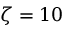<formula> <loc_0><loc_0><loc_500><loc_500>\zeta = 1 0</formula> 